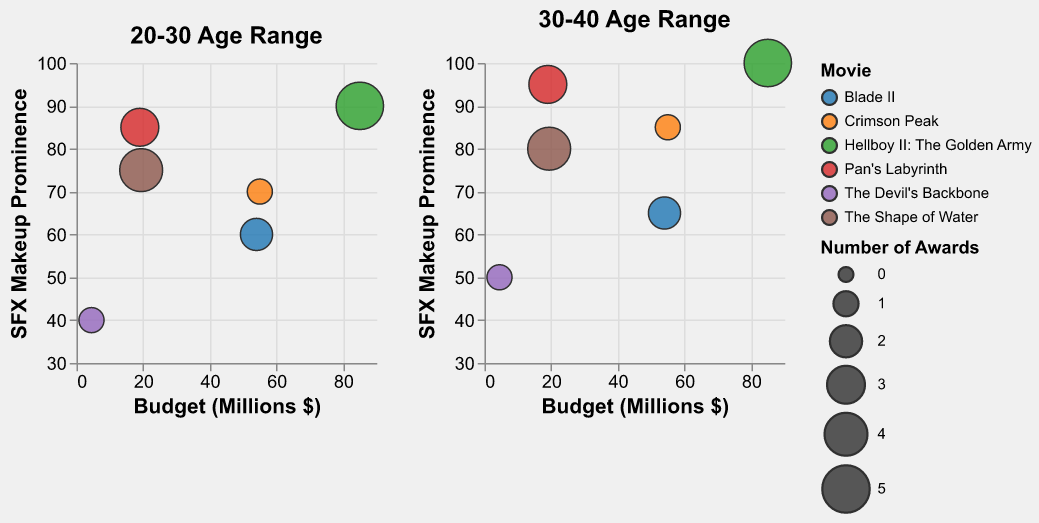How many movies have an actor age range of 20-30? In the bubble chart for the age range 20-30, each bubble represents a movie. By counting the distinct circles, we can determine the number of movies.
Answer: 6 Which movie in the 30-40 age range has the highest special effects makeup prominence? Refer to the subplot for the 30-40 age range and look for the highest y-axis value (Special Effects Makeup Prominence).
Answer: Hellboy II: The Golden Army What is the budget of "Crimson Peak" in the 20-30 age range? Look at the bubble corresponding to "Crimson Peak" in the 20-30 subplot and note the x-axis value (Budget).
Answer: 55 million dollars Which age range has a higher average special effects makeup prominence across all movies? Calculate the average special effects makeup prominence for each age range: (85+90+70+75+60+40)/6 for 20-30 and (95+100+85+80+65+50)/6 for 30-40. Compare the two averages.
Answer: 30-40 How does the budget compare between "Pan's Labyrinth" and "Hellboy II: The Golden Army" in the 30-40 age range? Compare the x-axis budget values for these two movies in the 30-40 age range subplot.
Answer: Hellboy II: The Golden Army has a higher budget What is the total number of awards for movies with actors in the 20-30 age range? Sum the size attribute (Number of Awards) for all bubbles in the 20-30 subplot (3+5+1+4+2+1).
Answer: 16 awards Which two movies have the least and most special effects makeup prominence in the 20-30 age range? Identify the lowest and highest y-axis values in the 20-30 age range subplot, and note the corresponding movies.
Answer: The Devil’s Backbone (least) and Hellboy II: The Golden Army (most) What is the relationship between the budget and the number of awards for "The Shape of Water" in both age ranges? Look at "The Shape of Water" bubbles in both subplots, compare their x-axis (Budget) and size (Number of Awards) attributes.
Answer: Budget is 19.4 million and Number of Awards is 4 in both cases Which movie with an actor age range of 20-30 has the smallest number of awards, and what is its special effects makeup prominence? Find the smallest circle in the 20-30 subplot (smallest "Number of Awards") and note its corresponding y-axis value.
Answer: The Devil’s Backbone, 40 